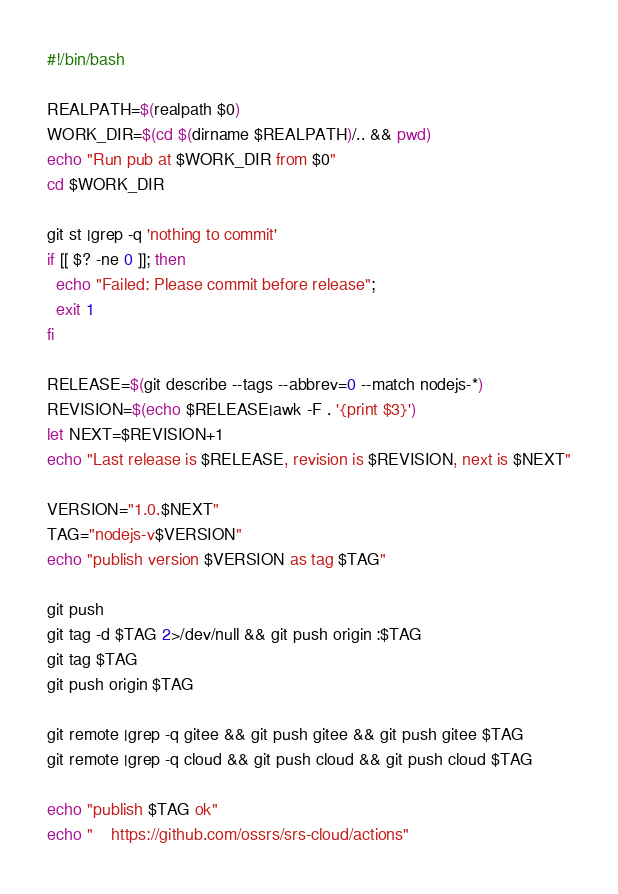Convert code to text. <code><loc_0><loc_0><loc_500><loc_500><_Bash_>#!/bin/bash

REALPATH=$(realpath $0)
WORK_DIR=$(cd $(dirname $REALPATH)/.. && pwd)
echo "Run pub at $WORK_DIR from $0"
cd $WORK_DIR

git st |grep -q 'nothing to commit'
if [[ $? -ne 0 ]]; then
  echo "Failed: Please commit before release";
  exit 1
fi

RELEASE=$(git describe --tags --abbrev=0 --match nodejs-*)
REVISION=$(echo $RELEASE|awk -F . '{print $3}')
let NEXT=$REVISION+1
echo "Last release is $RELEASE, revision is $REVISION, next is $NEXT"

VERSION="1.0.$NEXT"
TAG="nodejs-v$VERSION"
echo "publish version $VERSION as tag $TAG"

git push
git tag -d $TAG 2>/dev/null && git push origin :$TAG
git tag $TAG
git push origin $TAG

git remote |grep -q gitee && git push gitee && git push gitee $TAG
git remote |grep -q cloud && git push cloud && git push cloud $TAG

echo "publish $TAG ok"
echo "    https://github.com/ossrs/srs-cloud/actions"

</code> 